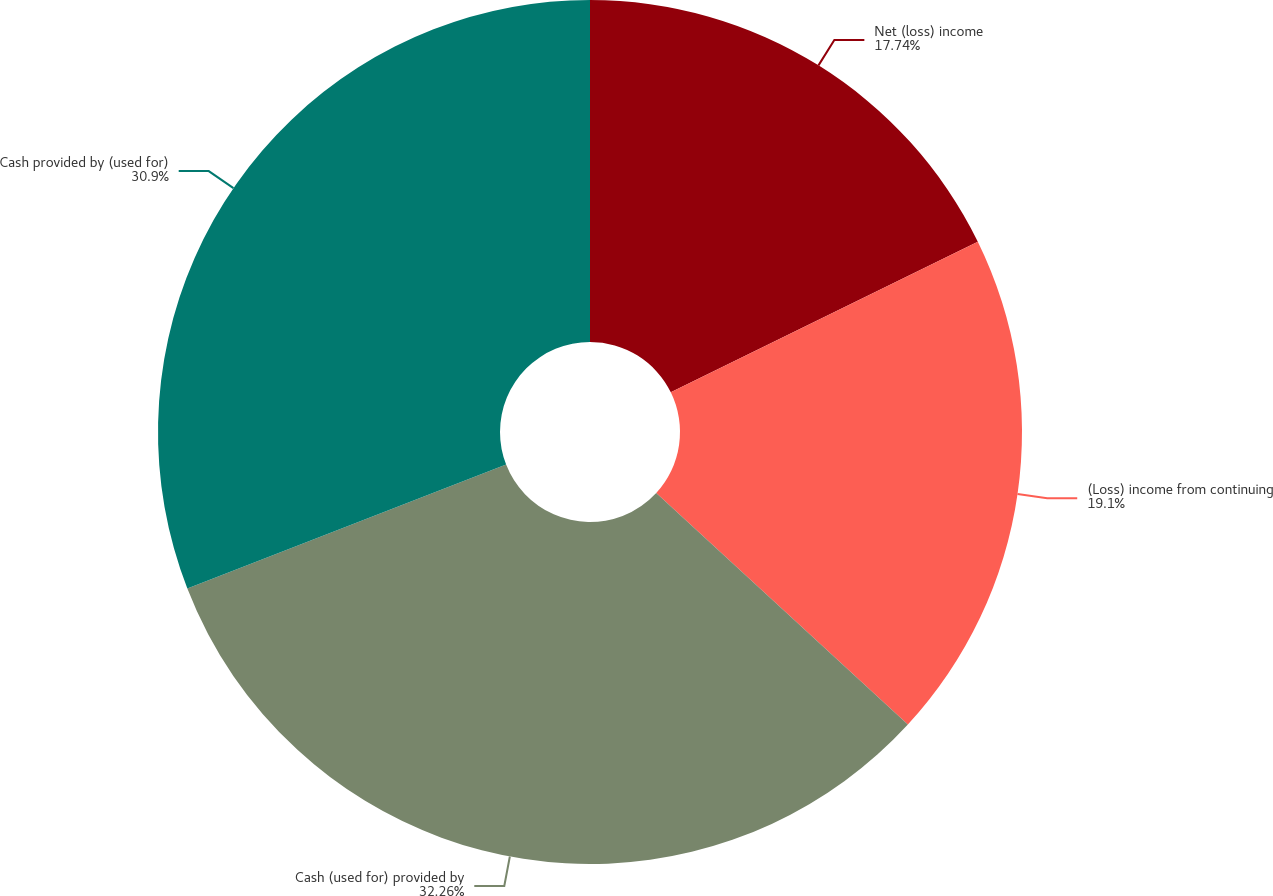Convert chart. <chart><loc_0><loc_0><loc_500><loc_500><pie_chart><fcel>Net (loss) income<fcel>(Loss) income from continuing<fcel>Cash (used for) provided by<fcel>Cash provided by (used for)<nl><fcel>17.74%<fcel>19.1%<fcel>32.26%<fcel>30.9%<nl></chart> 